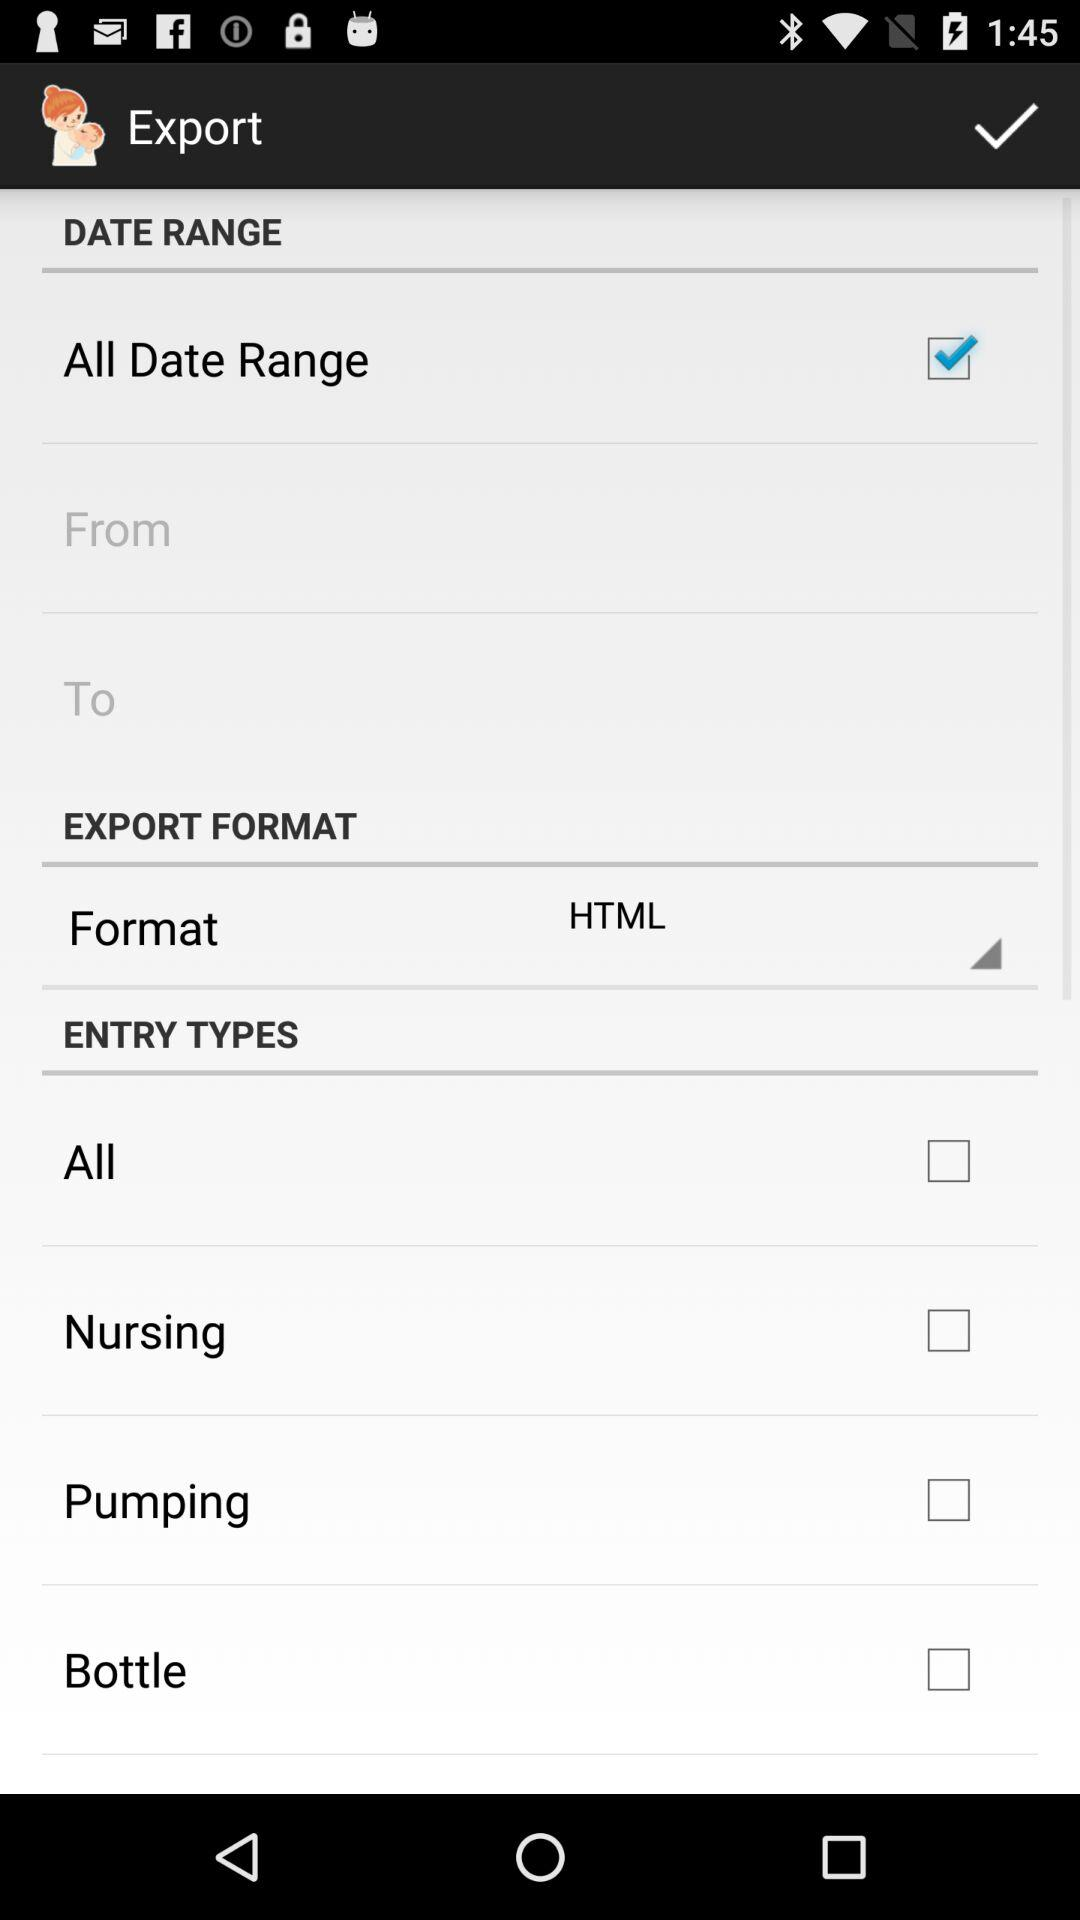What is the status of "All Data Range"? The status is on. 